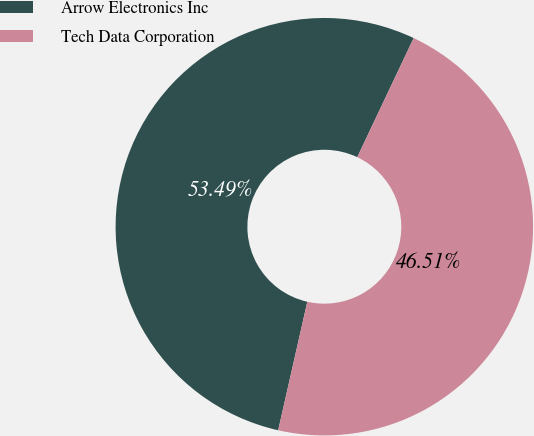<chart> <loc_0><loc_0><loc_500><loc_500><pie_chart><fcel>Arrow Electronics Inc<fcel>Tech Data Corporation<nl><fcel>53.49%<fcel>46.51%<nl></chart> 